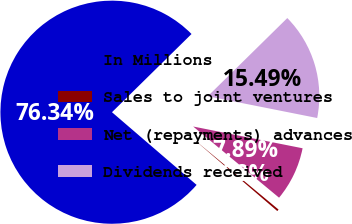Convert chart to OTSL. <chart><loc_0><loc_0><loc_500><loc_500><pie_chart><fcel>In Millions<fcel>Sales to joint ventures<fcel>Net (repayments) advances<fcel>Dividends received<nl><fcel>76.34%<fcel>0.28%<fcel>7.89%<fcel>15.49%<nl></chart> 